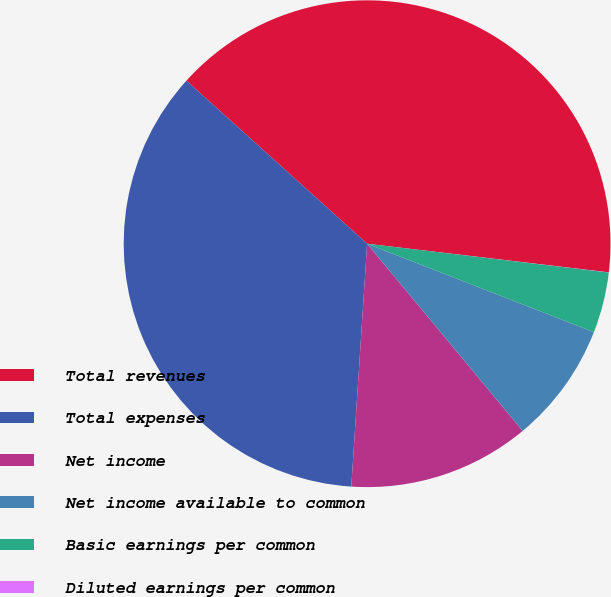Convert chart. <chart><loc_0><loc_0><loc_500><loc_500><pie_chart><fcel>Total revenues<fcel>Total expenses<fcel>Net income<fcel>Net income available to common<fcel>Basic earnings per common<fcel>Diluted earnings per common<nl><fcel>40.2%<fcel>35.65%<fcel>12.07%<fcel>8.05%<fcel>4.03%<fcel>0.01%<nl></chart> 